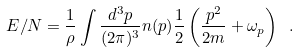Convert formula to latex. <formula><loc_0><loc_0><loc_500><loc_500>E / N = \frac { 1 } { \rho } \int \frac { d ^ { 3 } p } { ( 2 \pi ) ^ { 3 } } n ( p ) \frac { 1 } { 2 } \left ( \frac { p ^ { 2 } } { 2 m } + \omega _ { p } \right ) \ .</formula> 